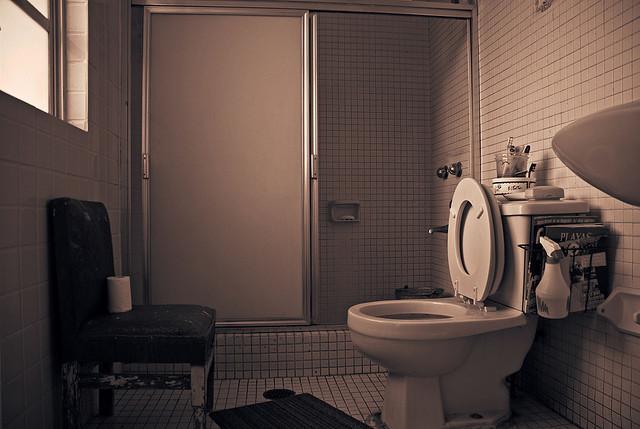Was a man the last person to pee in the toilet?
Keep it brief. Yes. Is the bathroom out of toilet paper?
Answer briefly. No. Is this room functional?
Answer briefly. Yes. Is this a photograph or is it an architectural drawing?
Write a very short answer. Photograph. Is the toilet seat up?
Write a very short answer. Yes. Is the toilet clean?
Keep it brief. Yes. Is there a window?
Give a very brief answer. Yes. What is on the stool?
Keep it brief. Toilet paper. How many types of tile is shown?
Write a very short answer. 2. Is that a new chair in front of the toilet?
Answer briefly. No. How many black containers are on top of the toilet?
Answer briefly. 0. What is sitting on the back of the toilet?
Quick response, please. Containers. What is hanging from the side of the toilet?
Be succinct. Cleaner. Where is the tissue box?
Keep it brief. On chair. Can you see through the shower door?
Concise answer only. No. Is this a nice bathroom?
Quick response, please. No. 